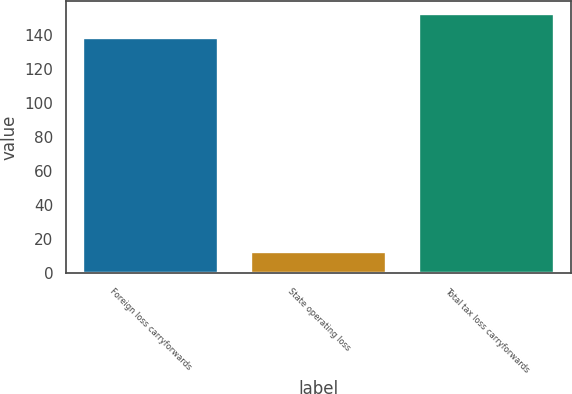<chart> <loc_0><loc_0><loc_500><loc_500><bar_chart><fcel>Foreign loss carryforwards<fcel>State operating loss<fcel>Total tax loss carryforwards<nl><fcel>138.1<fcel>12.5<fcel>151.91<nl></chart> 